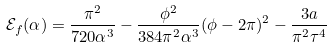Convert formula to latex. <formula><loc_0><loc_0><loc_500><loc_500>\mathcal { E } _ { f } ( \alpha ) = \frac { \pi ^ { 2 } } { 7 2 0 \alpha ^ { 3 } } - \frac { \phi ^ { 2 } } { 3 8 4 \pi ^ { 2 } \alpha ^ { 3 } } ( \phi - 2 \pi ) ^ { 2 } - \frac { 3 a } { \pi ^ { 2 } \tau ^ { 4 } }</formula> 